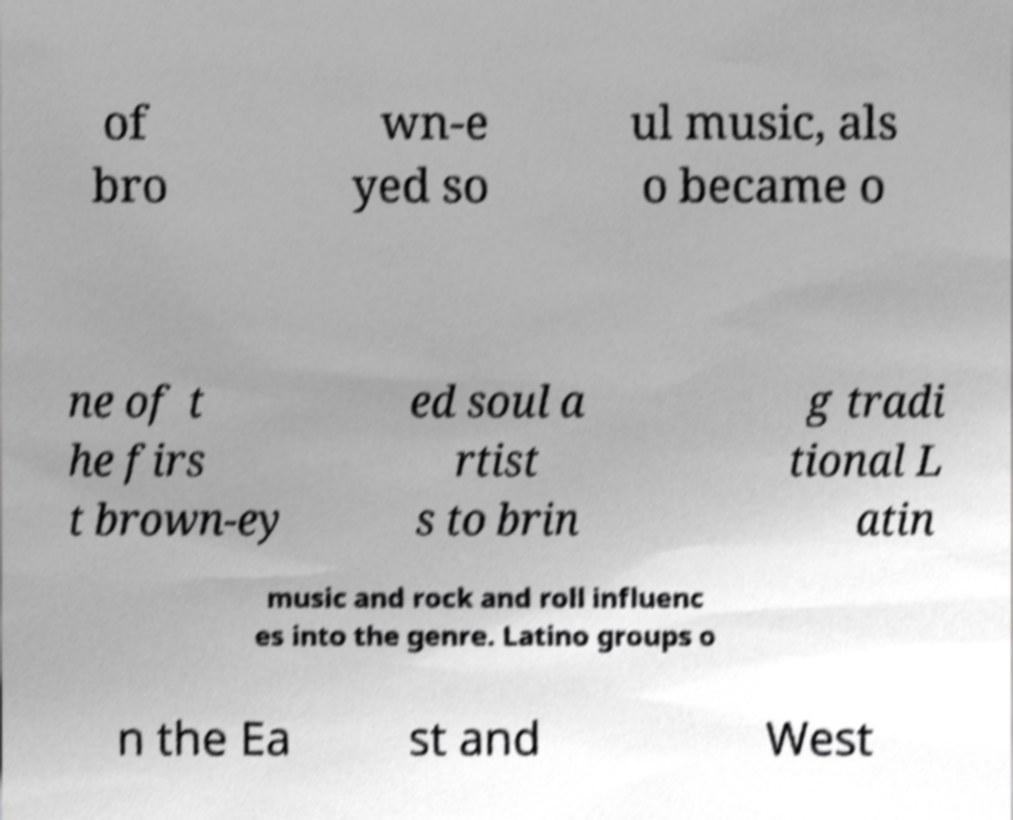Could you assist in decoding the text presented in this image and type it out clearly? of bro wn-e yed so ul music, als o became o ne of t he firs t brown-ey ed soul a rtist s to brin g tradi tional L atin music and rock and roll influenc es into the genre. Latino groups o n the Ea st and West 